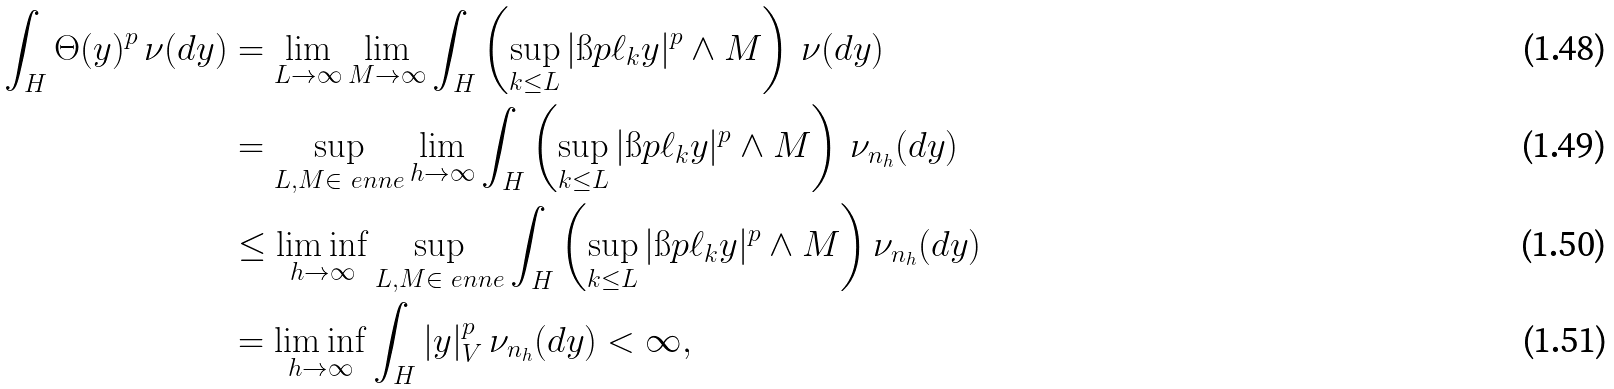<formula> <loc_0><loc_0><loc_500><loc_500>\int _ { H } \Theta ( y ) ^ { p } \, \nu ( d y ) & = \lim _ { L \to \infty } \lim _ { M \to \infty } \int _ { H } \left ( \sup _ { k \leq L } | \i p { \ell _ { k } } { y } | ^ { p } \wedge M \right ) \, \nu ( d y ) \\ & = \sup _ { L , M \in \ e n n e } \lim _ { h \to \infty } \int _ { H } \left ( \sup _ { k \leq L } | \i p { \ell _ { k } } { y } | ^ { p } \wedge M \right ) \, \nu _ { n _ { h } } ( d y ) \\ & \leq \liminf _ { h \to \infty } \sup _ { L , M \in \ e n n e } \int _ { H } \left ( \sup _ { k \leq L } | \i p { \ell _ { k } } { y } | ^ { p } \wedge M \right ) \nu _ { n _ { h } } ( d y ) \\ & = \liminf _ { h \to \infty } \int _ { H } | y | ^ { p } _ { V } \, \nu _ { n _ { h } } ( d y ) < \infty ,</formula> 